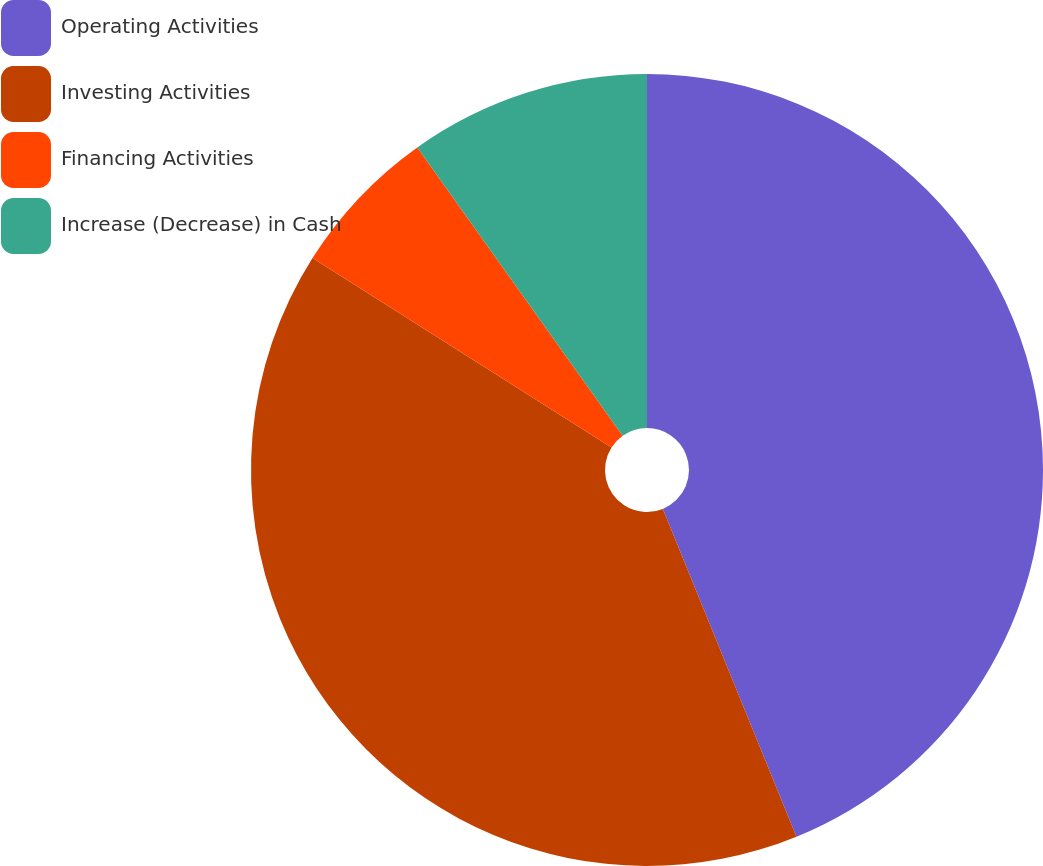<chart> <loc_0><loc_0><loc_500><loc_500><pie_chart><fcel>Operating Activities<fcel>Investing Activities<fcel>Financing Activities<fcel>Increase (Decrease) in Cash<nl><fcel>43.84%<fcel>40.15%<fcel>6.16%<fcel>9.85%<nl></chart> 